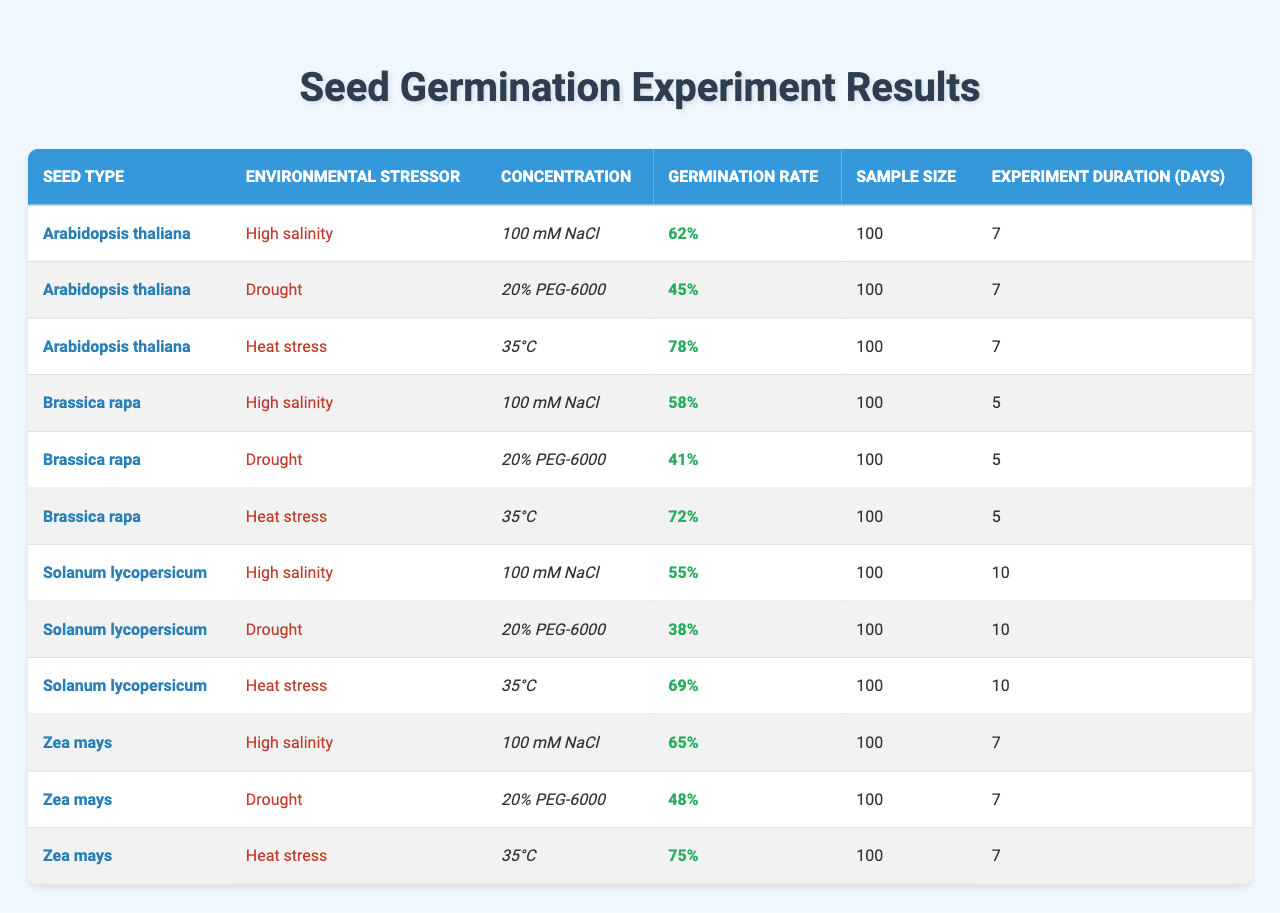What is the germination rate of Arabidopsis thaliana under heat stress? The table shows that the germination rate of Arabidopsis thaliana exposed to heat stress at 35°C is 78%.
Answer: 78% Which seed type shows the highest germination rate under drought conditions? By examining the drought conditions, Arabidopsis thaliana has a germination rate of 45%, Brassica rapa has 41%, and Solanum lycopersicum has 38%. Thus, Arabidopsis thaliana has the highest rate.
Answer: Arabidopsis thaliana How many total seeds were sampled for Zea mays across all environmental stressors? Each environmental stressor for Zea mays had a sample size of 100. There are three stressors, so the total is 100 + 100 + 100 = 300.
Answer: 300 What is the average germination rate for seeds exposed to high salinity? The germination rates for high salinity are 62% (Arabidopsis thaliana), 58% (Brassica rapa), 55% (Solanum lycopersicum), and 65% (Zea mays). Adding these gives 62 + 58 + 55 + 65 = 240, and dividing by 4 gives an average of 240/4 = 60%.
Answer: 60% Is the germination rate of Solanum lycopersicum higher under heat stress or drought conditions? Under heat stress, Solanum lycopersicum has a germination rate of 69%, and under drought, it has 38%. Therefore, the germination rate is higher under heat stress.
Answer: Yes Which seed type has the lowest germination rate when subjected to drought stress? The germination rates under drought are 45% (Arabidopsis thaliana), 41% (Brassica rapa), and 38% (Solanum lycopersicum). Solanum lycopersicum has the lowest rate at 38%.
Answer: Solanum lycopersicum What is the difference in germination rates for Brassica rapa between heat stress and high salinity? Brassica rapa's germination rate under heat stress is 72% and under high salinity is 58%. The difference is 72 - 58 = 14%.
Answer: 14% Which environmental stressor had the highest overall germination rate across all seed types? The highest rates under each stressor are: heat stress (78% for Arabidopsis thaliana), high salinity (65% for Zea mays), and drought (45% for Arabidopsis thaliana). The maximum is 78% for heat stress.
Answer: Heat stress Calculate the percentage increase in germination rate for Zea mays from high salinity to heat stress. The rates are 65% for high salinity and 75% for heat stress. The increase is 75 - 65 = 10%. To find the percentage increase, use (10/65) * 100 ≈ 15.38%.
Answer: 15.38% Do any seeds have the same germination rate for both high salinity and drought? Examining the rates, Arabidopsis thaliana has 62% (high salinity) and 45% (drought), Brassica rapa has 58% (high salinity) and 41% (drought), Solanum lycopersicum has 55% (high salinity) and 38% (drought), Zea mays has 65% (high salinity) and 48% (drought). None are the same.
Answer: No 